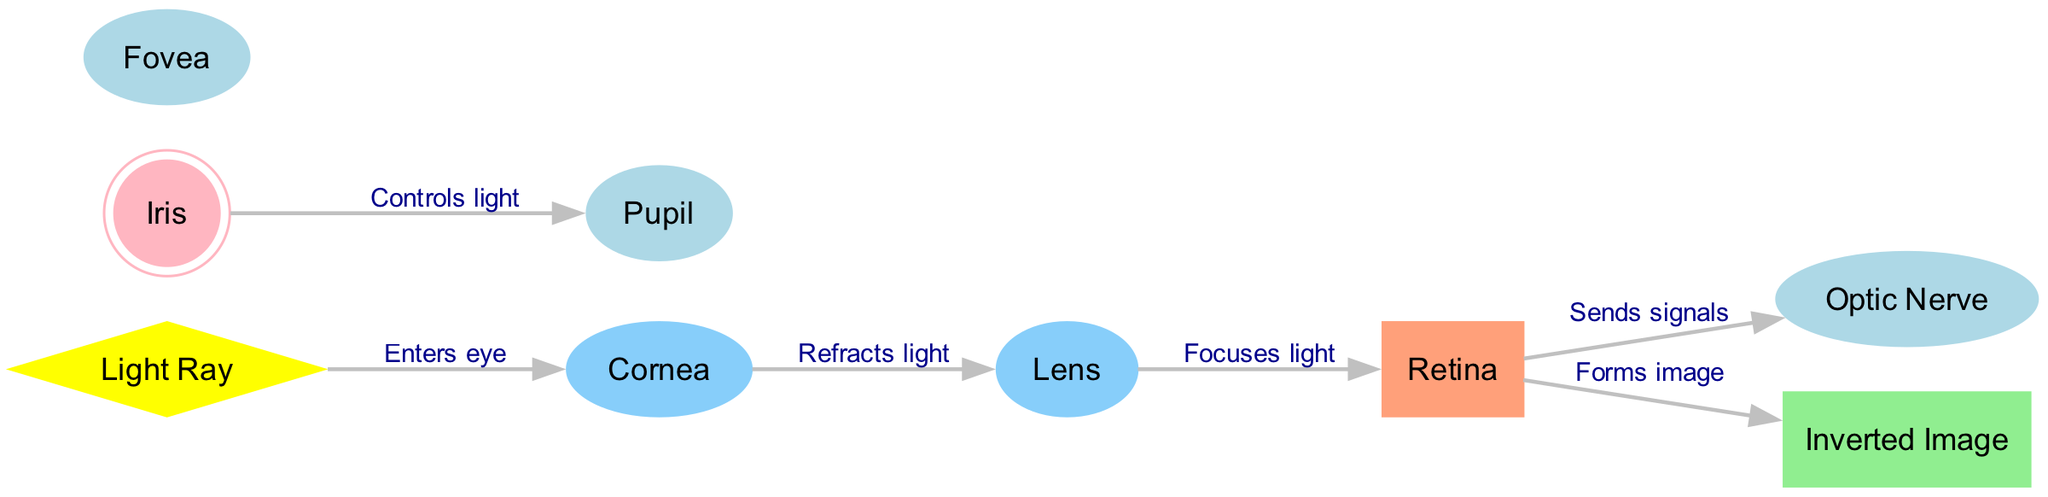What is the first structure that the light ray encounters? The light ray enters the diagram at the "Light Ray" node and the first connection is to the "Cornea" node, indicating that the light ray encounters the cornea first.
Answer: Cornea How many main structures are involved in the image formation process? By counting the nodes directly involved in the process from "Light Ray" to "Inverted Image," we identify six key structures: Cornea, Lens, Retina, Optic Nerve, and Fovea, plus the Pupil which controls light and the Iris regulating the Pupil. Therefore, there are a total of six main structures involved.
Answer: Six What is the role of the lens in this diagram? According to the edges, the lens is highlighted as the structure that receives refracted light from the cornea and focuses it onto the retina. This information indicates the specific function of the lens in the diagram.
Answer: Focuses light How does light travel after passing through the lens? After the light passes through the lens, it progresses directly to the retina as indicated by the edge that connects lens to retina specifically labeled "Focuses light," and then from the retina to forms the image.
Answer: To the retina Which node sends signals to the optic nerve? The edge from the "Retina" to "Optic Nerve" is labeled "Sends signals," which indicates that the retina sends signals to the optic nerve, highlighting the connection and function between these two structures.
Answer: Retina What controls the amount of light entering the eye? The "Iris" is responsible for controlling the amount of light entering the eye as indicated by the edge from the iris to the pupil labeled "Controls light." This reflects the role of the iris in the diagram.
Answer: Iris What type of image is formed on the retina? The edge from the "Retina" to the "Inverted Image" is labeled "Forms image," which indicates that the structure forms an image, specifically describing the nature of the image as inverted, making it clear it is an inverted image.
Answer: Inverted Image Which structure is a double circle in this diagram? The iris is visually represented in the diagram as a double circle, which is a distinguishing feature indicated in the descriptions of the node shapes within the diagram.
Answer: Iris What is the sequence of nodes from light entry to image formation? Starting from the "Light Ray," the sequence follows from "Cornea" to "Lens," then to "Retina," and finally to "Inverted Image." This sequence is traced through the edges that connect these nodes sequentially representing the flow of light leading to image formation.
Answer: Light Ray, Cornea, Lens, Retina, Inverted Image 